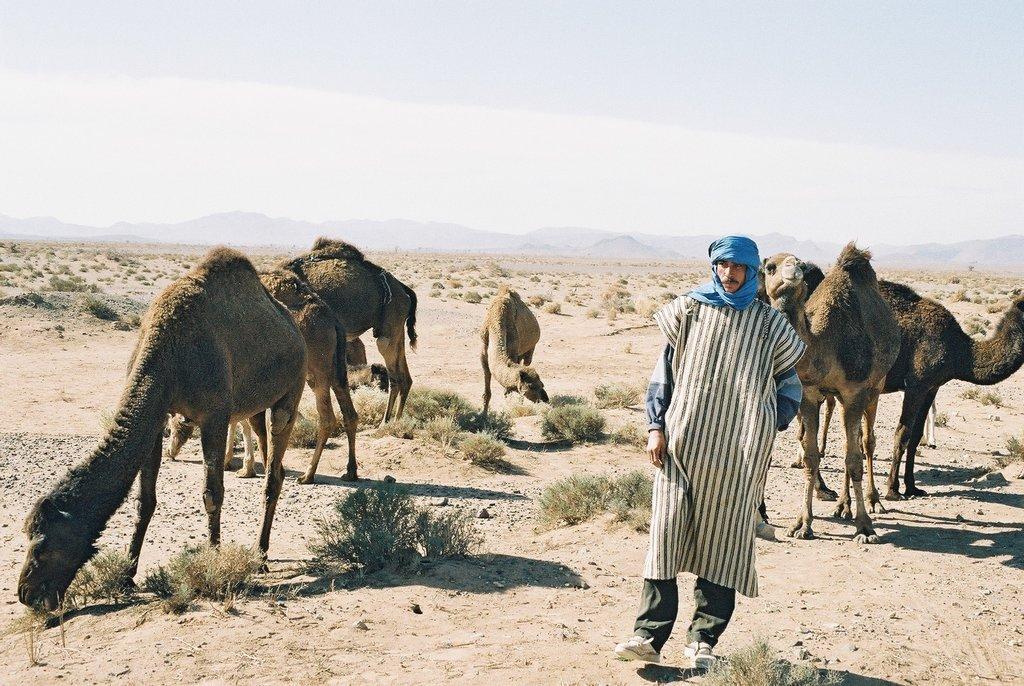Could you give a brief overview of what you see in this image? In this image there are few camels, small bushes, persons visible in the foreground, in the middle may be there are hills, at the top there is the sky. 